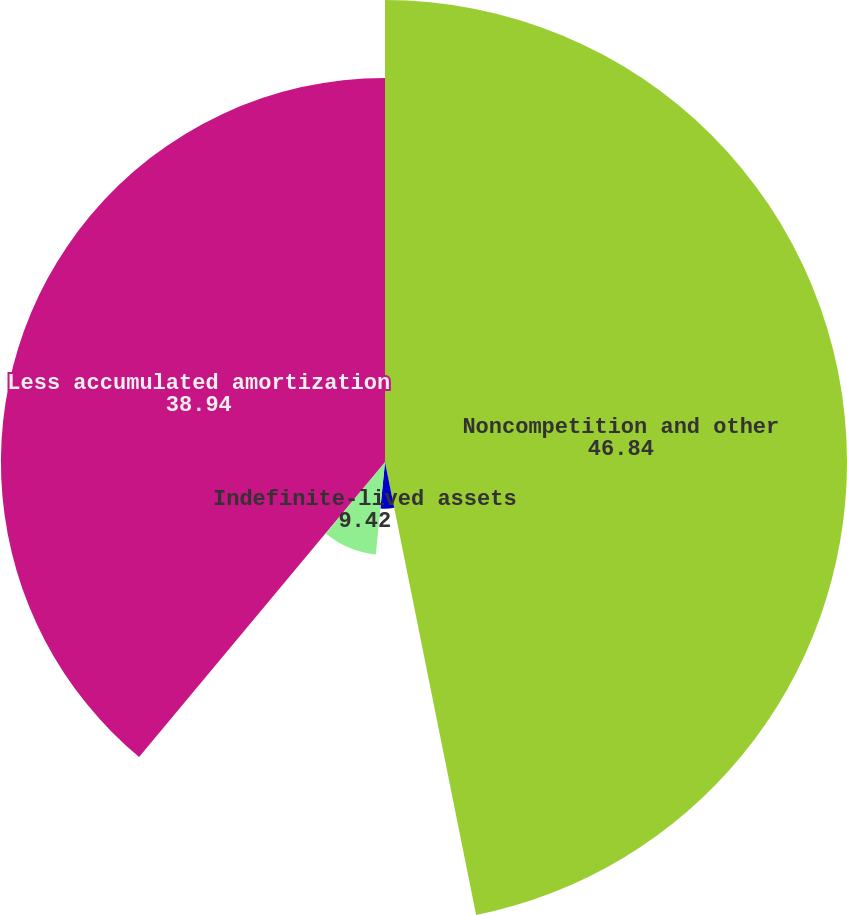<chart> <loc_0><loc_0><loc_500><loc_500><pie_chart><fcel>Noncompetition and other<fcel>Lease agreements<fcel>Indefinite-lived assets<fcel>Other<fcel>Less accumulated amortization<nl><fcel>46.84%<fcel>4.74%<fcel>9.42%<fcel>0.06%<fcel>38.94%<nl></chart> 